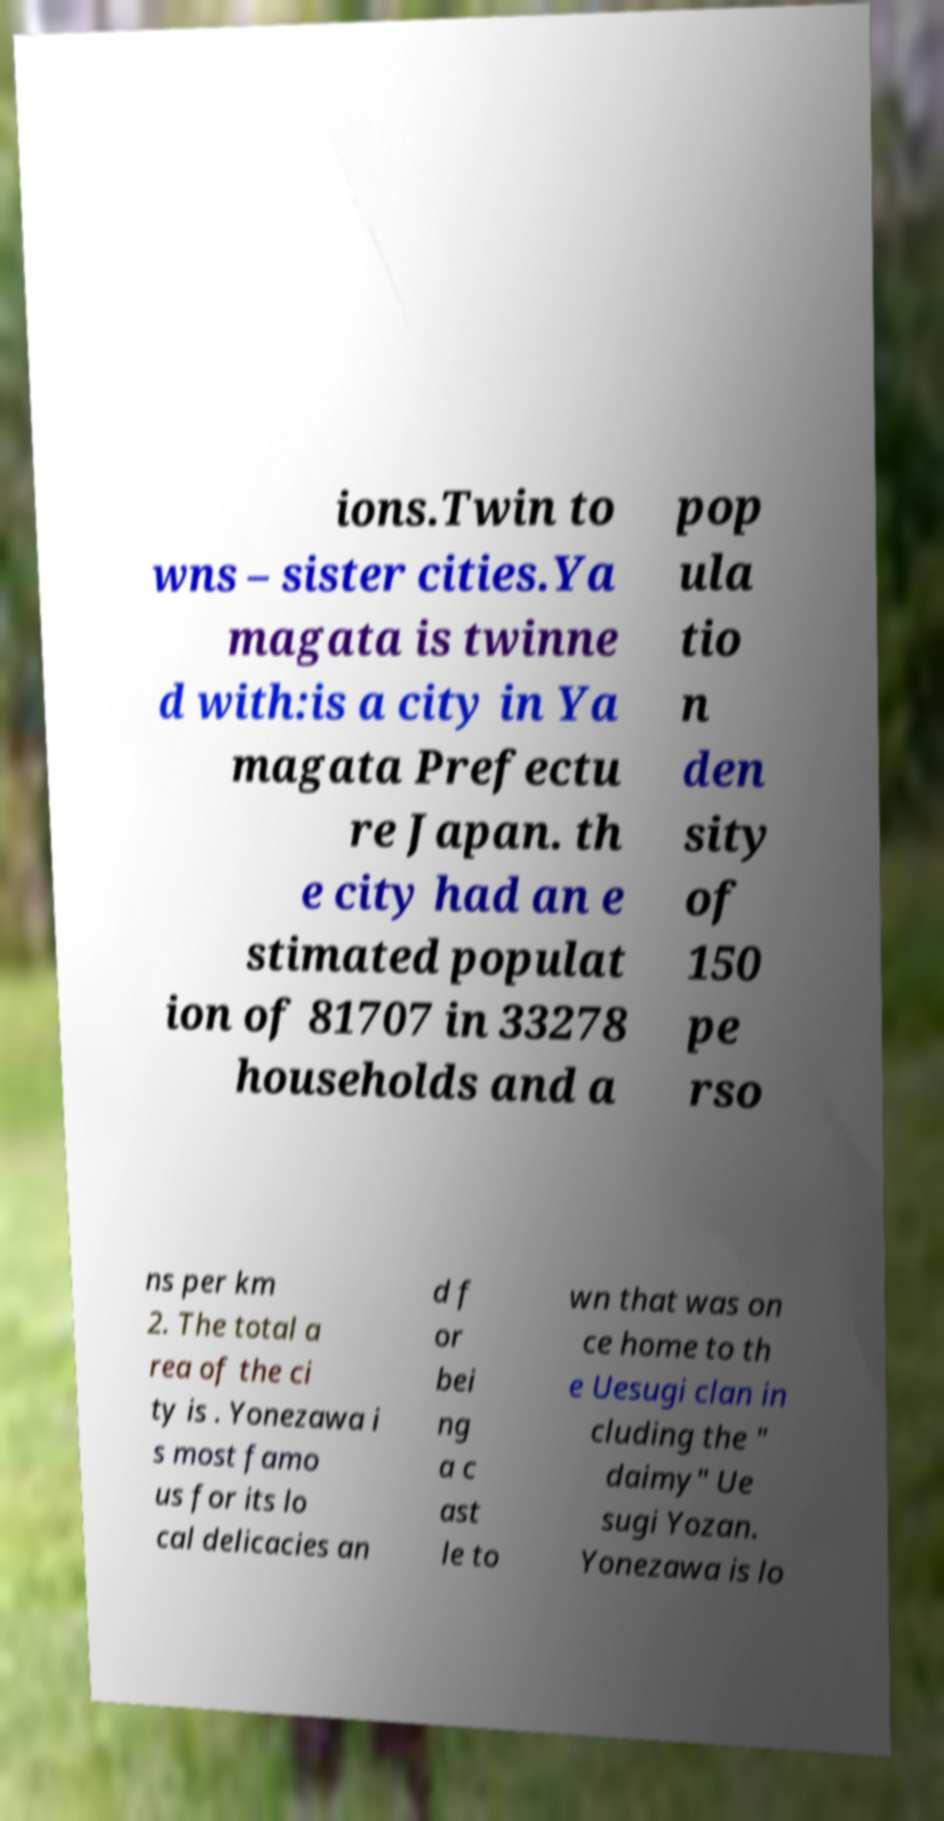For documentation purposes, I need the text within this image transcribed. Could you provide that? ions.Twin to wns – sister cities.Ya magata is twinne d with:is a city in Ya magata Prefectu re Japan. th e city had an e stimated populat ion of 81707 in 33278 households and a pop ula tio n den sity of 150 pe rso ns per km 2. The total a rea of the ci ty is . Yonezawa i s most famo us for its lo cal delicacies an d f or bei ng a c ast le to wn that was on ce home to th e Uesugi clan in cluding the " daimy" Ue sugi Yozan. Yonezawa is lo 